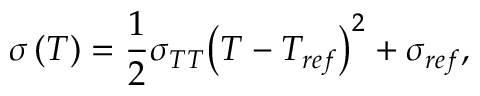<formula> <loc_0><loc_0><loc_500><loc_500>\sigma \left ( T \right ) = \frac { 1 } { 2 } { \sigma _ { T T } } { \left ( { T - { T _ { r e f } } } \right ) ^ { 2 } } + { \sigma _ { r e f } } ,</formula> 